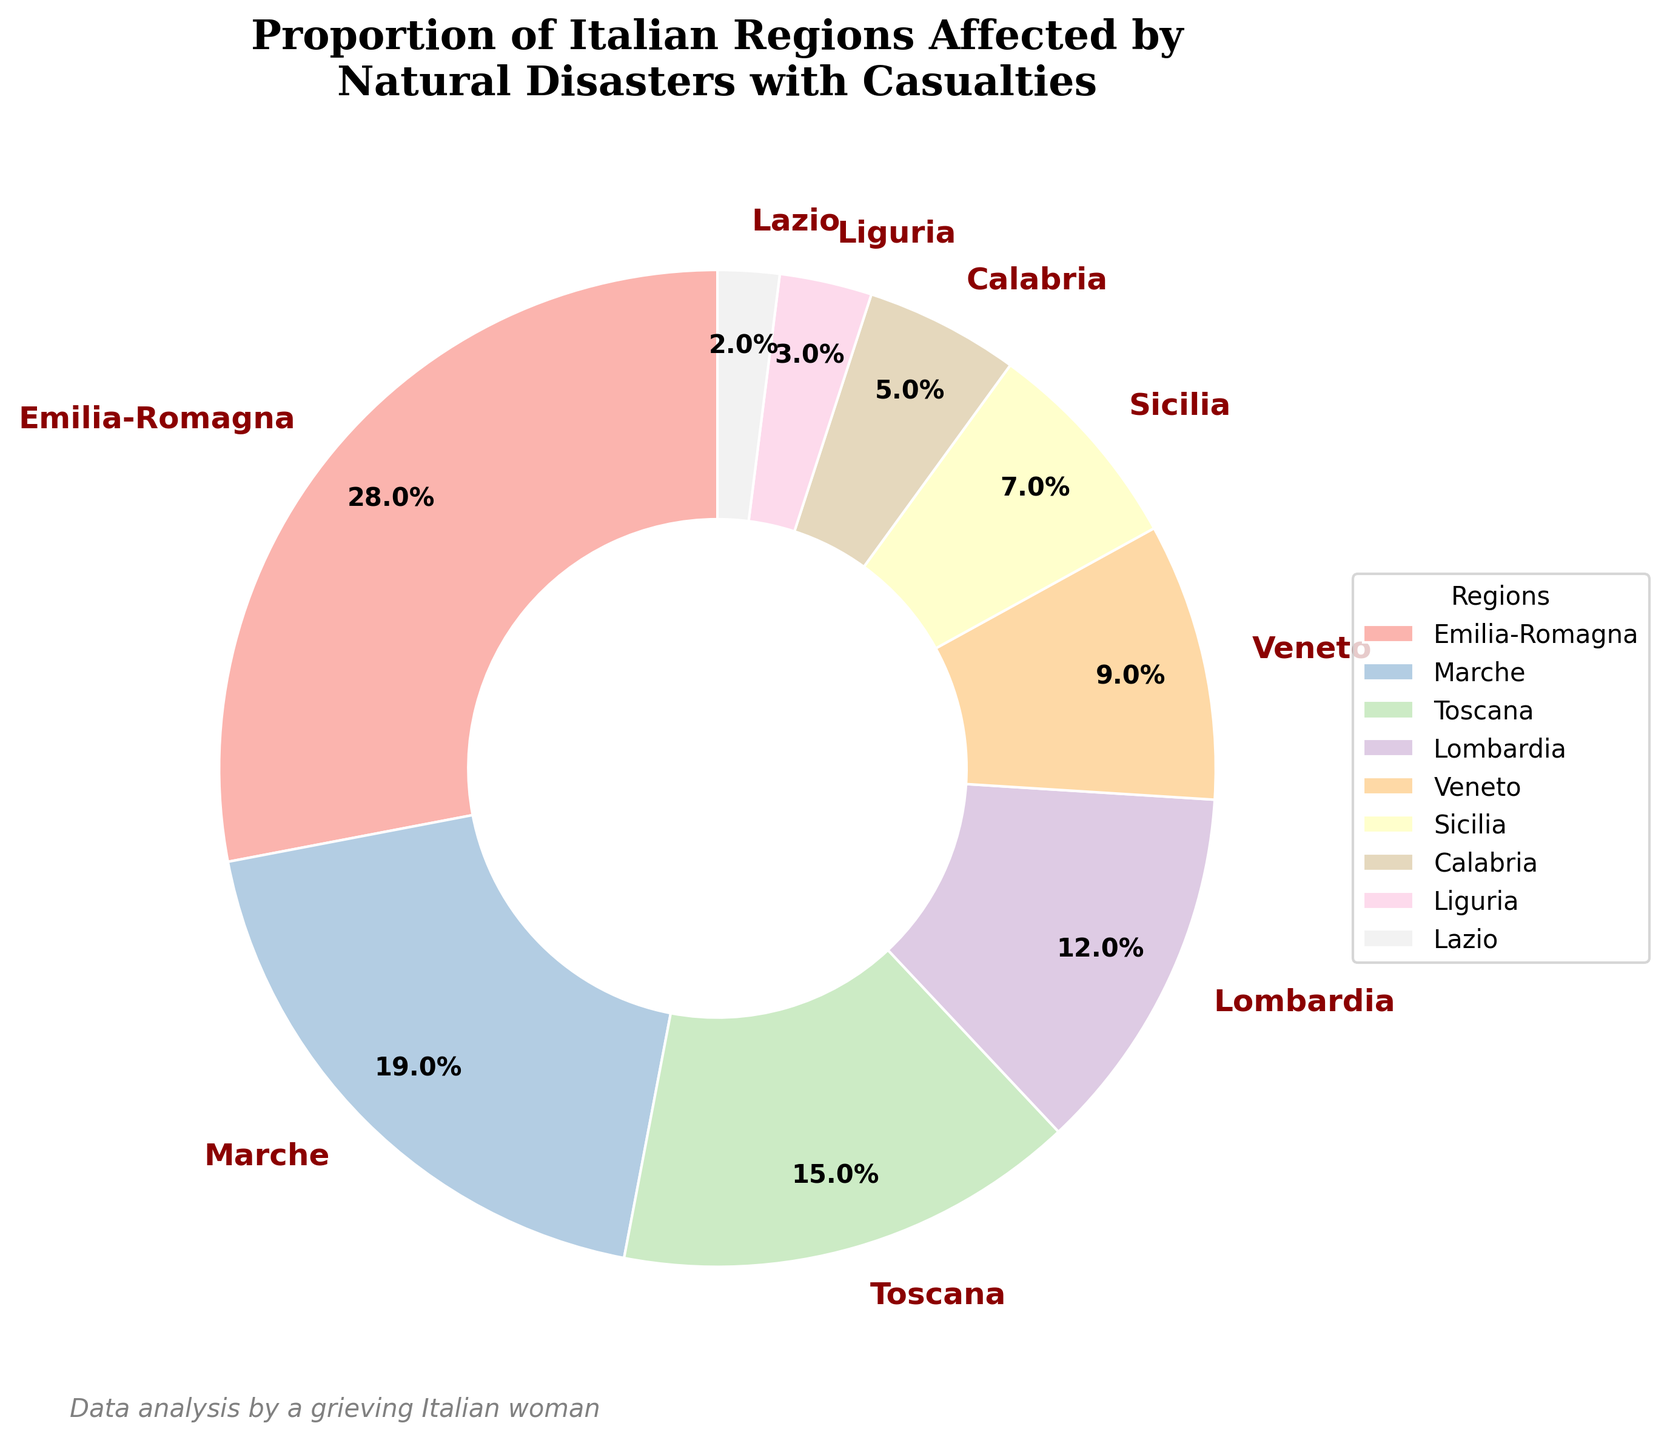What region has the largest proportion of casualties due to natural disasters? By referring to the pie chart, you can see that Emilia-Romagna has the largest wedge with 28% of casualties.
Answer: Emilia-Romagna Which two regions together account for more than 40% of the casualties? Emilia-Romagna accounts for 28% and Marche accounts for 19%; together they sum up to 47%, which is more than 40%.
Answer: Emilia-Romagna and Marche What is the total percentage of casualties for Sicilia, Calabria, and Lazio combined? According to the chart, Sicilia accounts for 7%, Calabria for 5%, and Lazio for 2%. Adding these together gives 7% + 5% + 2% = 14%.
Answer: 14% Which region has a smaller proportion of casualties: Veneto or Lombardia? Veneto accounts for 9% and Lombardia accounts for 12%. Comparing the two, Veneto has the smaller proportion.
Answer: Veneto What is the difference in the proportion of casualties between Toscana and Liguria? Toscana accounts for 15% and Liguria for 3%. The difference between them is 15% - 3% = 12%.
Answer: 12% Which color represents the region with the smallest proportion of casualties? The pie chart employs a color scheme where each region has a distinct color. Lazio, which has the smallest proportion (2%), is represented by the lightest shade in the Pastel1 color scheme.
Answer: Lightest color How many regions have a proportion of casualties greater than 10%? From the chart, Emilia-Romagna (28%), Marche (19%), Toscana (15%), and Lombardia (12%) each have proportions greater than 10%. This counts to 4 regions.
Answer: 4 If we combine the percentages of Veneto and Calabria, what would the resulting wedge's size be compared to Emilia-Romagna? Veneto accounts for 9% and Calabria for 5%. Adding these together gives 14%. Since Emilia-Romagna is 28%, the combined size of Veneto and Calabria is half of Emilia-Romagna.
Answer: Half Is the sum of the proportions of Marche and Sicilia greater than that of Lombardia and Liguria combined? Marche has 19% and Sicilia 7%, which together sum up to 26%. Lombardia has 12% and Liguria 3%, which together sum up to 15%. Since 26% is greater than 15%, the answer is yes.
Answer: Yes 